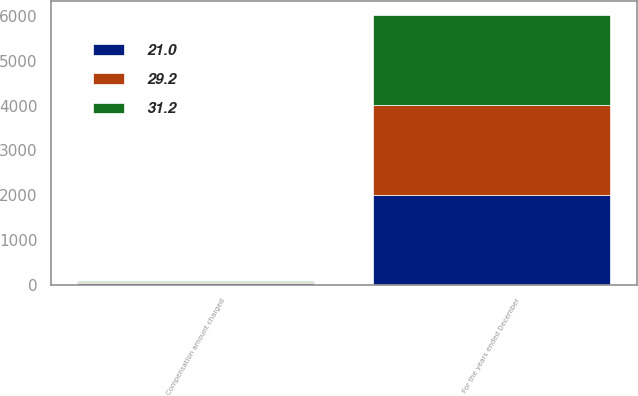Convert chart. <chart><loc_0><loc_0><loc_500><loc_500><stacked_bar_chart><ecel><fcel>For the years ended December<fcel>Compensation amount charged<nl><fcel>31.2<fcel>2012<fcel>31.2<nl><fcel>29.2<fcel>2011<fcel>21<nl><fcel>21<fcel>2010<fcel>29.2<nl></chart> 